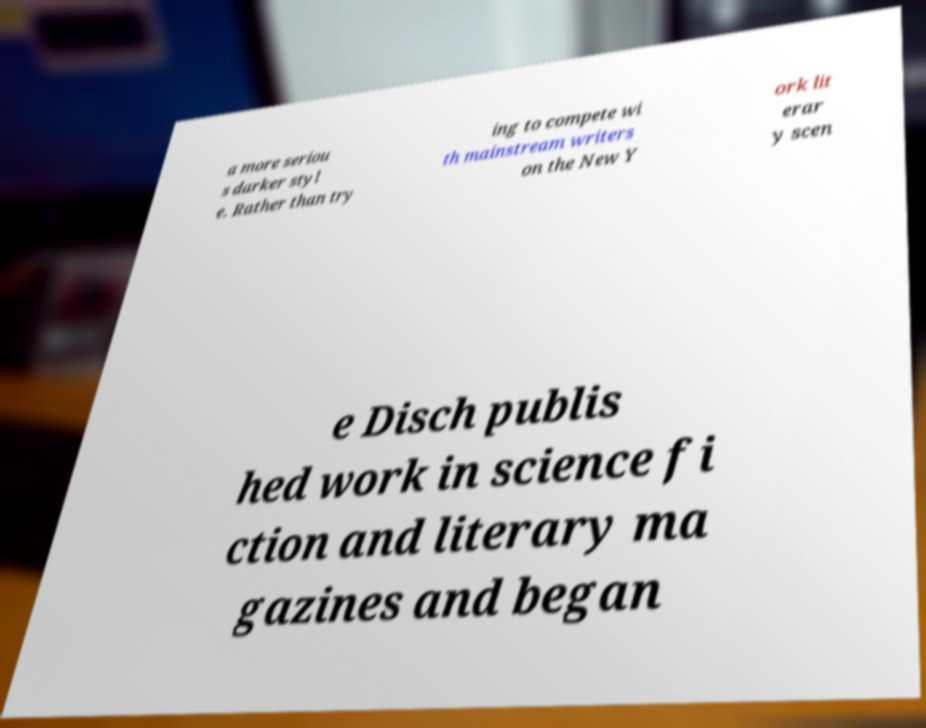Could you assist in decoding the text presented in this image and type it out clearly? a more seriou s darker styl e. Rather than try ing to compete wi th mainstream writers on the New Y ork lit erar y scen e Disch publis hed work in science fi ction and literary ma gazines and began 